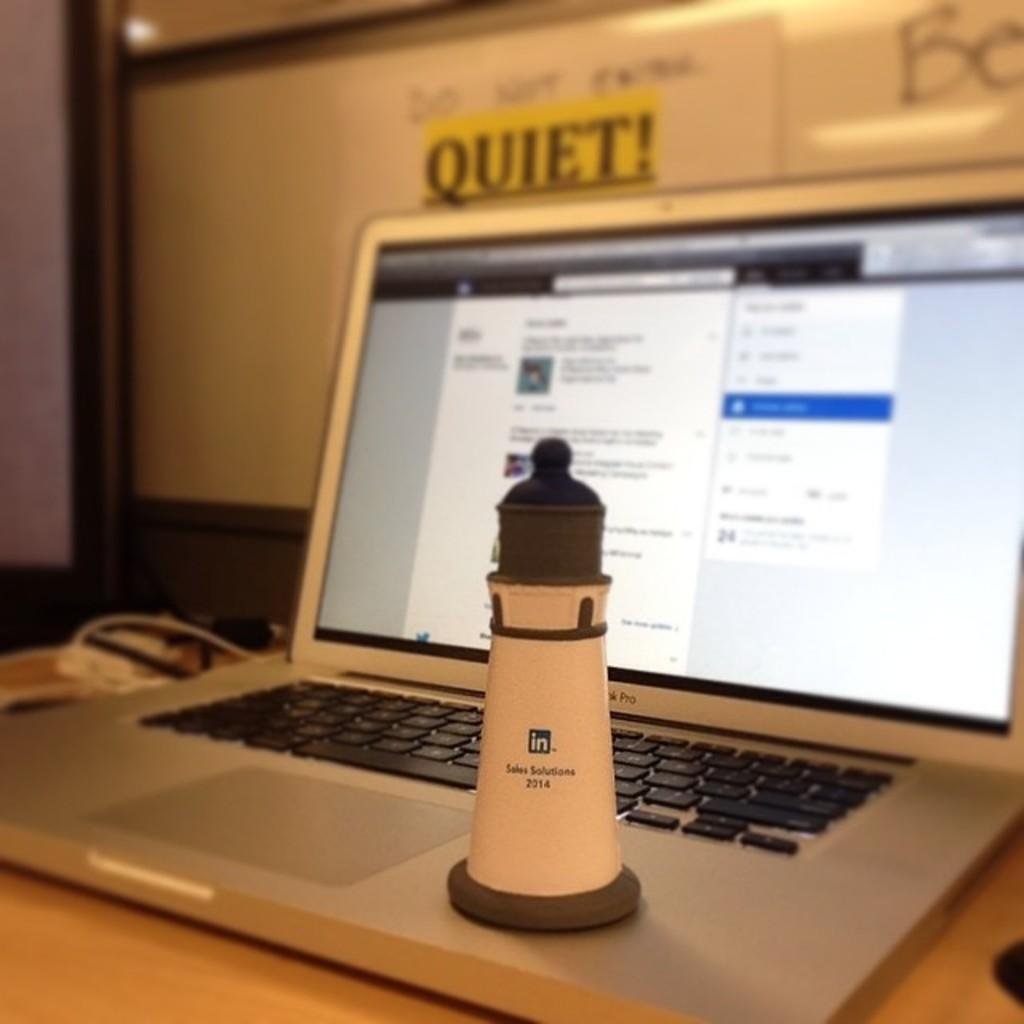Could you give a brief overview of what you see in this image? In the image there is a laptop and on the laptop there is some object and the background of the laptop is blurry. 